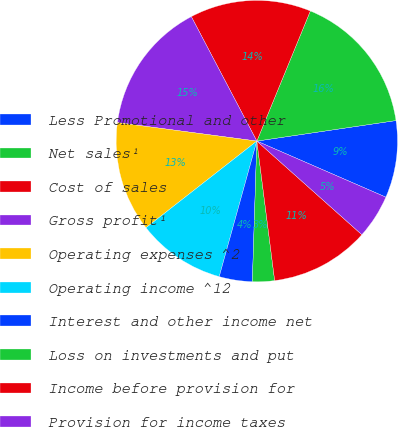<chart> <loc_0><loc_0><loc_500><loc_500><pie_chart><fcel>Less Promotional and other<fcel>Net sales¹<fcel>Cost of sales<fcel>Gross profit¹<fcel>Operating expenses ^2<fcel>Operating income ^12<fcel>Interest and other income net<fcel>Loss on investments and put<fcel>Income before provision for<fcel>Provision for income taxes<nl><fcel>8.86%<fcel>16.46%<fcel>13.92%<fcel>15.19%<fcel>12.66%<fcel>10.13%<fcel>3.8%<fcel>2.53%<fcel>11.39%<fcel>5.06%<nl></chart> 